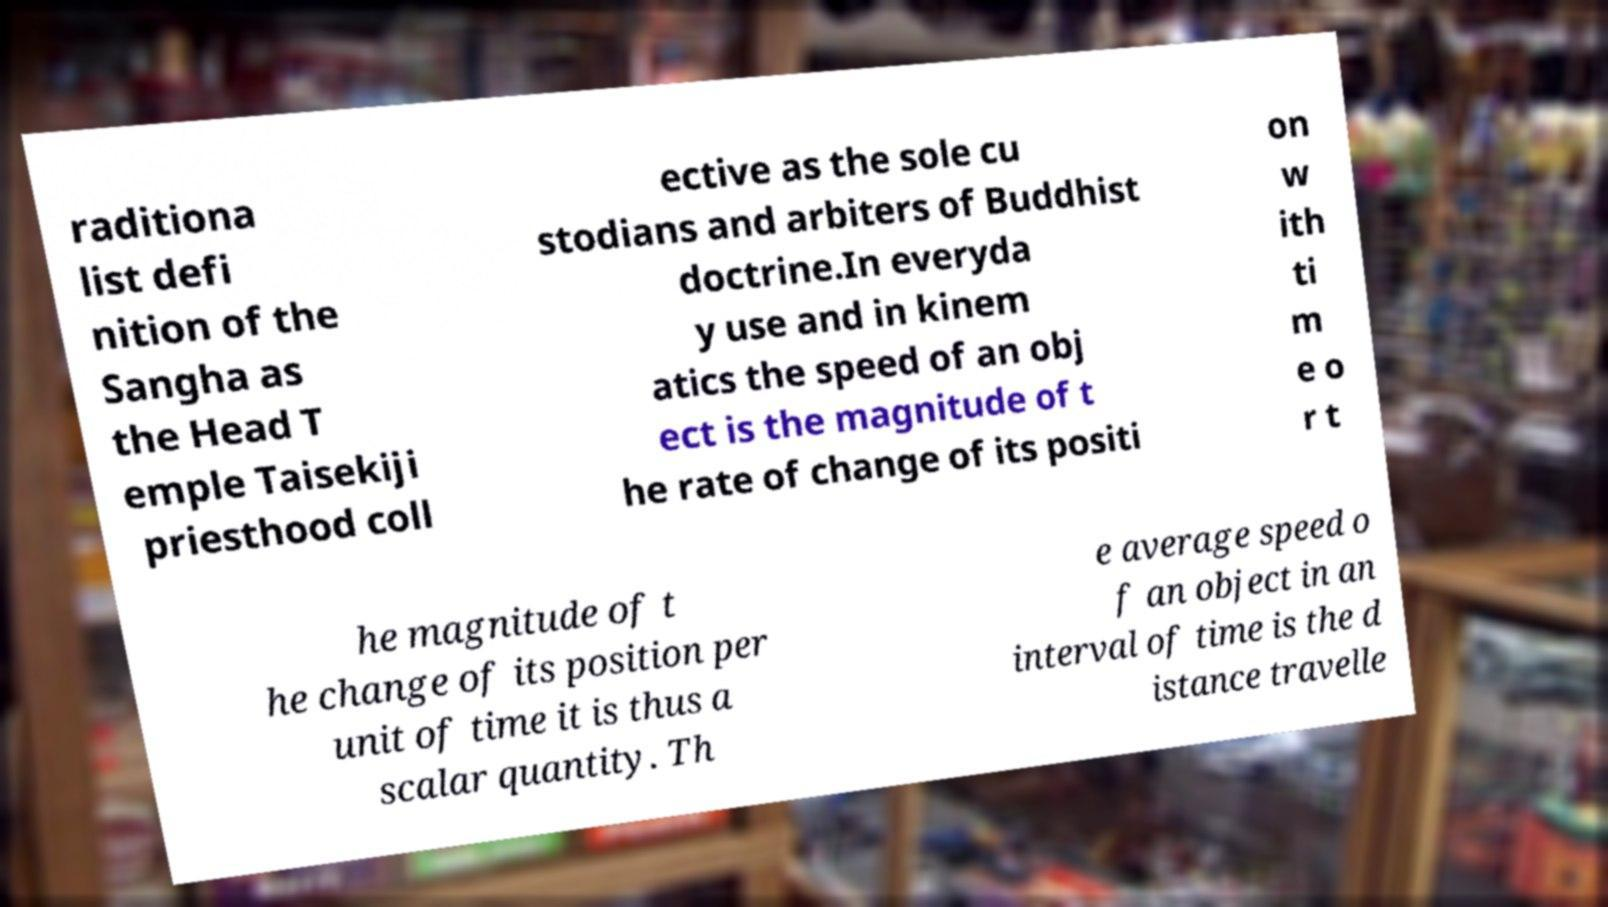Can you read and provide the text displayed in the image?This photo seems to have some interesting text. Can you extract and type it out for me? raditiona list defi nition of the Sangha as the Head T emple Taisekiji priesthood coll ective as the sole cu stodians and arbiters of Buddhist doctrine.In everyda y use and in kinem atics the speed of an obj ect is the magnitude of t he rate of change of its positi on w ith ti m e o r t he magnitude of t he change of its position per unit of time it is thus a scalar quantity. Th e average speed o f an object in an interval of time is the d istance travelle 